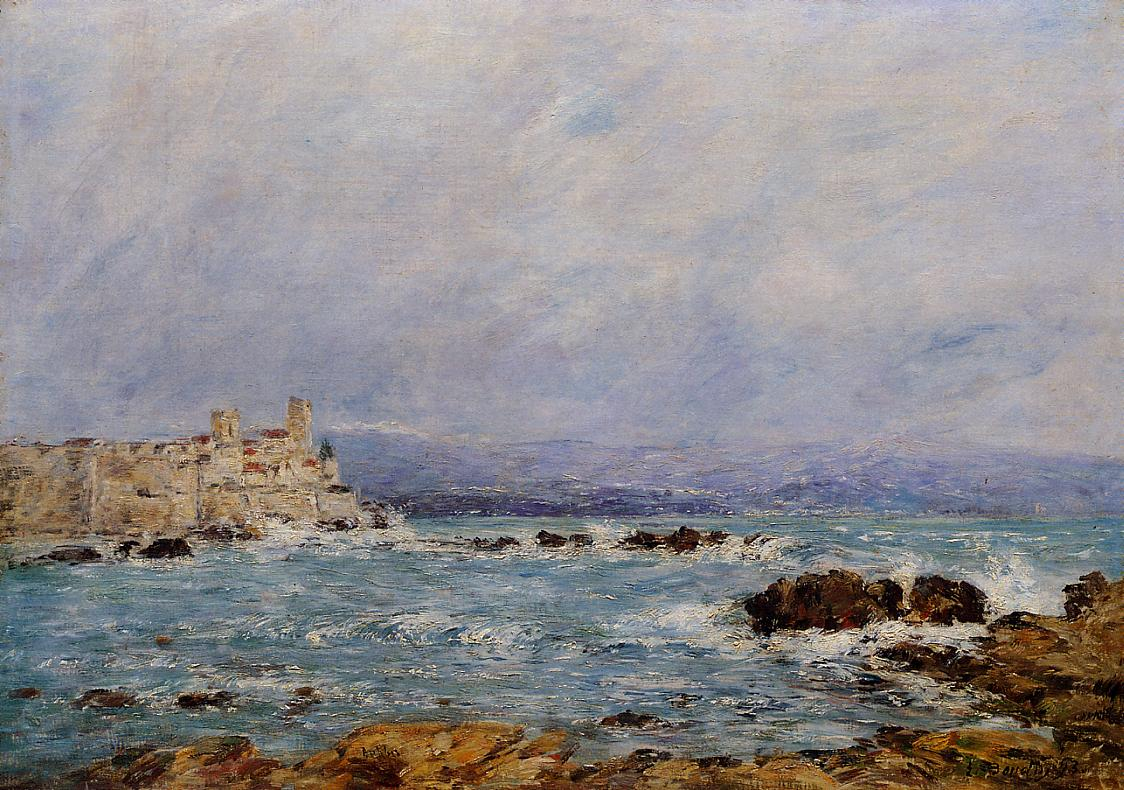What are the key elements in this picture? The image depicts a captivating impressionist landscape, likely an oil painting on canvas. The scene captures a rocky coastline with dark green moss-covered rocks in the foreground. The sea, painted in darker blues with dynamic whitecaps, adds a sense of movement. In the background, a beige castle sits majestically on a cliff overlooking the sea. The light blue sky, adorned with wisps of clouds, introduces tranquility. The painting is signed near the lower right corner, attributing it to the renowned artist. The composition and color palette are classic of the impressionist style, known for focusing on light and color nuances. 